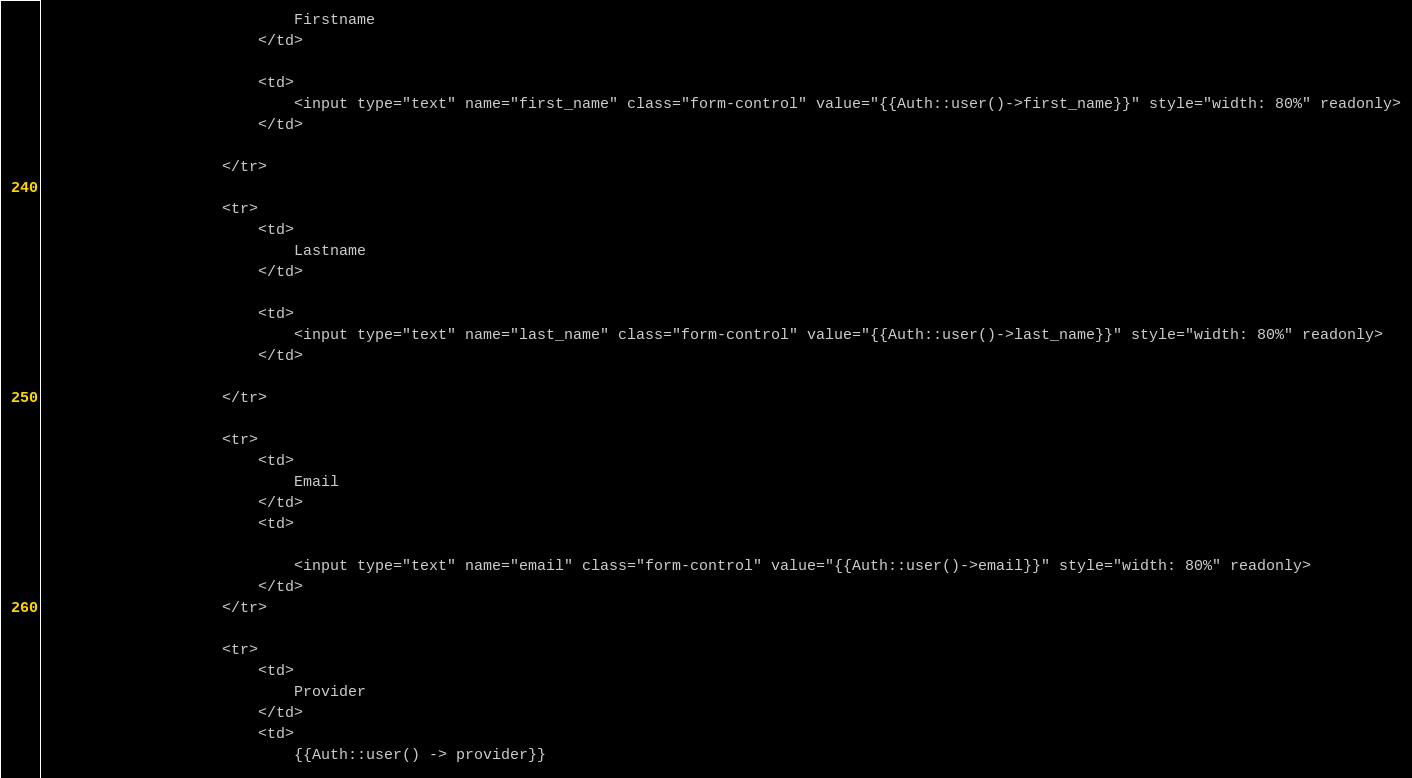<code> <loc_0><loc_0><loc_500><loc_500><_PHP_>                            Firstname
                        </td>

                        <td>
                            <input type="text" name="first_name" class="form-control" value="{{Auth::user()->first_name}}" style="width: 80%" readonly>
                        </td>

                    </tr>

                    <tr>
                        <td>
                            Lastname
                        </td>

                        <td>
                            <input type="text" name="last_name" class="form-control" value="{{Auth::user()->last_name}}" style="width: 80%" readonly>
                        </td>

                    </tr>

                    <tr>
                        <td>
                            Email
                        </td>
                        <td>

                            <input type="text" name="email" class="form-control" value="{{Auth::user()->email}}" style="width: 80%" readonly>
                        </td>
                    </tr>

                    <tr>
                        <td>
                            Provider
                        </td>
                        <td>
                            {{Auth::user() -> provider}}</code> 